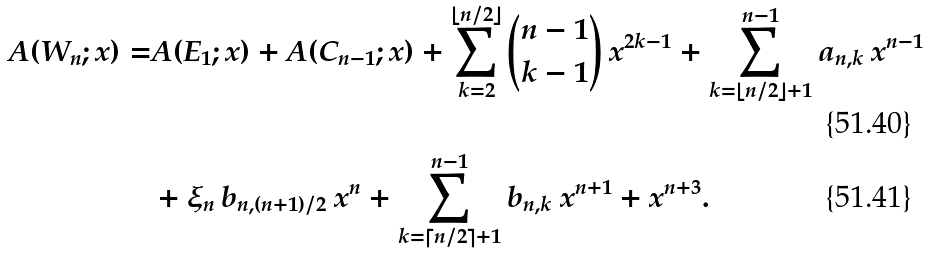<formula> <loc_0><loc_0><loc_500><loc_500>A ( W _ { n } ; x ) = & A ( E _ { 1 } ; x ) + A ( C _ { n - 1 } ; x ) + \sum _ { k = 2 } ^ { \lfloor n / 2 \rfloor } { n - 1 \choose k - 1 } \ x ^ { 2 k - 1 } + \sum _ { k = \lfloor n / 2 \rfloor + 1 } ^ { n - 1 } a _ { n , k } \ x ^ { n - 1 } \\ & + \xi _ { n } \, b _ { n , ( n + 1 ) / 2 } \ x ^ { n } + \sum _ { k = \lceil n / 2 \rceil + 1 } ^ { n - 1 } b _ { n , k } \ x ^ { n + 1 } + x ^ { n + 3 } .</formula> 